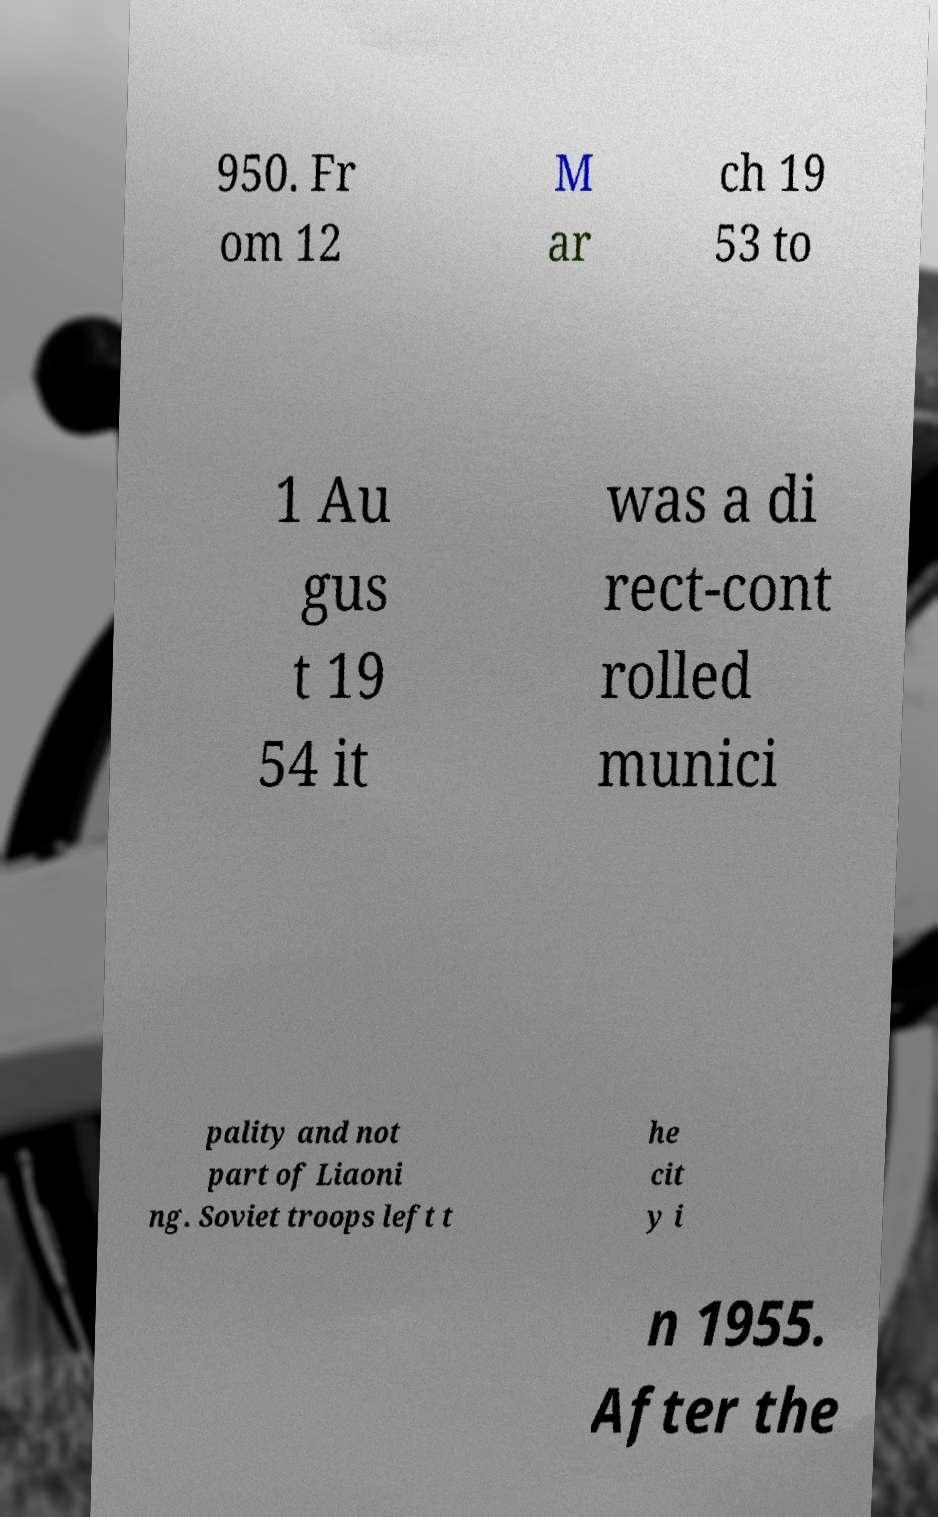I need the written content from this picture converted into text. Can you do that? 950. Fr om 12 M ar ch 19 53 to 1 Au gus t 19 54 it was a di rect-cont rolled munici pality and not part of Liaoni ng. Soviet troops left t he cit y i n 1955. After the 